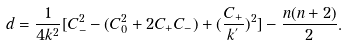<formula> <loc_0><loc_0><loc_500><loc_500>d = \frac { 1 } { 4 k ^ { 2 } } [ C _ { - } ^ { 2 } - ( C _ { 0 } ^ { 2 } + 2 C _ { + } C _ { - } ) + ( \frac { C _ { + } } { k ^ { ^ { \prime } } } ) ^ { 2 } ] - \frac { n ( n + 2 ) } { 2 } .</formula> 